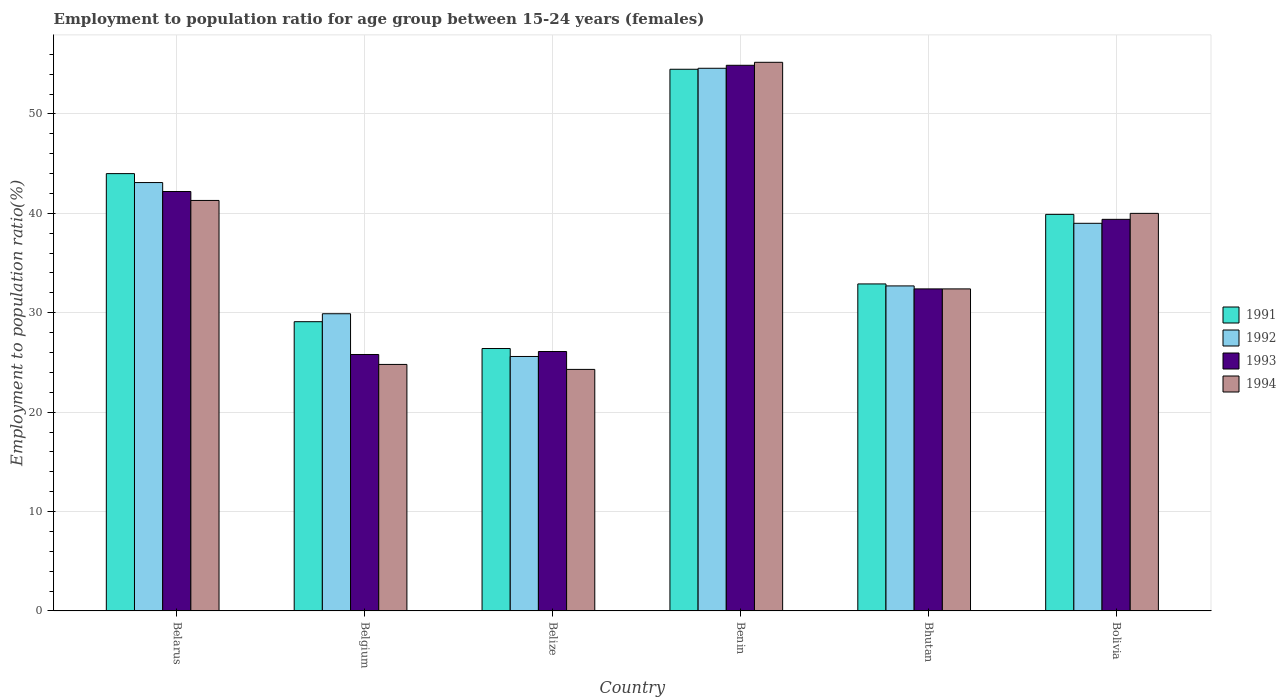How many groups of bars are there?
Provide a short and direct response. 6. Are the number of bars on each tick of the X-axis equal?
Your answer should be very brief. Yes. How many bars are there on the 6th tick from the right?
Offer a very short reply. 4. What is the label of the 5th group of bars from the left?
Provide a short and direct response. Bhutan. What is the employment to population ratio in 1994 in Belgium?
Offer a very short reply. 24.8. Across all countries, what is the maximum employment to population ratio in 1994?
Offer a very short reply. 55.2. Across all countries, what is the minimum employment to population ratio in 1992?
Give a very brief answer. 25.6. In which country was the employment to population ratio in 1991 maximum?
Keep it short and to the point. Benin. What is the total employment to population ratio in 1993 in the graph?
Offer a terse response. 220.8. What is the difference between the employment to population ratio in 1992 in Belize and that in Bolivia?
Offer a very short reply. -13.4. What is the difference between the employment to population ratio in 1994 in Belarus and the employment to population ratio in 1991 in Belize?
Provide a short and direct response. 14.9. What is the average employment to population ratio in 1993 per country?
Provide a short and direct response. 36.8. What is the difference between the employment to population ratio of/in 1993 and employment to population ratio of/in 1992 in Belarus?
Your response must be concise. -0.9. What is the ratio of the employment to population ratio in 1992 in Belgium to that in Benin?
Provide a succinct answer. 0.55. Is the employment to population ratio in 1992 in Belgium less than that in Bolivia?
Provide a succinct answer. Yes. What is the difference between the highest and the second highest employment to population ratio in 1992?
Offer a very short reply. -11.5. What is the difference between the highest and the lowest employment to population ratio in 1991?
Ensure brevity in your answer.  28.1. Is the sum of the employment to population ratio in 1992 in Belgium and Benin greater than the maximum employment to population ratio in 1994 across all countries?
Offer a very short reply. Yes. Is it the case that in every country, the sum of the employment to population ratio in 1992 and employment to population ratio in 1994 is greater than the sum of employment to population ratio in 1991 and employment to population ratio in 1993?
Your answer should be compact. No. What does the 4th bar from the right in Belarus represents?
Make the answer very short. 1991. How many countries are there in the graph?
Your answer should be compact. 6. What is the difference between two consecutive major ticks on the Y-axis?
Make the answer very short. 10. Are the values on the major ticks of Y-axis written in scientific E-notation?
Provide a succinct answer. No. Does the graph contain any zero values?
Provide a succinct answer. No. How many legend labels are there?
Your answer should be compact. 4. What is the title of the graph?
Ensure brevity in your answer.  Employment to population ratio for age group between 15-24 years (females). Does "2001" appear as one of the legend labels in the graph?
Provide a succinct answer. No. What is the label or title of the X-axis?
Provide a succinct answer. Country. What is the Employment to population ratio(%) in 1992 in Belarus?
Ensure brevity in your answer.  43.1. What is the Employment to population ratio(%) in 1993 in Belarus?
Ensure brevity in your answer.  42.2. What is the Employment to population ratio(%) in 1994 in Belarus?
Give a very brief answer. 41.3. What is the Employment to population ratio(%) of 1991 in Belgium?
Your answer should be very brief. 29.1. What is the Employment to population ratio(%) of 1992 in Belgium?
Your response must be concise. 29.9. What is the Employment to population ratio(%) in 1993 in Belgium?
Your answer should be very brief. 25.8. What is the Employment to population ratio(%) in 1994 in Belgium?
Your answer should be compact. 24.8. What is the Employment to population ratio(%) of 1991 in Belize?
Your response must be concise. 26.4. What is the Employment to population ratio(%) in 1992 in Belize?
Provide a short and direct response. 25.6. What is the Employment to population ratio(%) in 1993 in Belize?
Your answer should be very brief. 26.1. What is the Employment to population ratio(%) of 1994 in Belize?
Give a very brief answer. 24.3. What is the Employment to population ratio(%) of 1991 in Benin?
Provide a succinct answer. 54.5. What is the Employment to population ratio(%) of 1992 in Benin?
Your response must be concise. 54.6. What is the Employment to population ratio(%) in 1993 in Benin?
Your answer should be very brief. 54.9. What is the Employment to population ratio(%) of 1994 in Benin?
Provide a succinct answer. 55.2. What is the Employment to population ratio(%) of 1991 in Bhutan?
Your answer should be very brief. 32.9. What is the Employment to population ratio(%) in 1992 in Bhutan?
Offer a very short reply. 32.7. What is the Employment to population ratio(%) in 1993 in Bhutan?
Offer a terse response. 32.4. What is the Employment to population ratio(%) of 1994 in Bhutan?
Ensure brevity in your answer.  32.4. What is the Employment to population ratio(%) of 1991 in Bolivia?
Offer a terse response. 39.9. What is the Employment to population ratio(%) in 1992 in Bolivia?
Ensure brevity in your answer.  39. What is the Employment to population ratio(%) of 1993 in Bolivia?
Provide a succinct answer. 39.4. Across all countries, what is the maximum Employment to population ratio(%) in 1991?
Your answer should be very brief. 54.5. Across all countries, what is the maximum Employment to population ratio(%) in 1992?
Your answer should be compact. 54.6. Across all countries, what is the maximum Employment to population ratio(%) in 1993?
Provide a short and direct response. 54.9. Across all countries, what is the maximum Employment to population ratio(%) of 1994?
Keep it short and to the point. 55.2. Across all countries, what is the minimum Employment to population ratio(%) in 1991?
Make the answer very short. 26.4. Across all countries, what is the minimum Employment to population ratio(%) in 1992?
Your answer should be compact. 25.6. Across all countries, what is the minimum Employment to population ratio(%) in 1993?
Provide a succinct answer. 25.8. Across all countries, what is the minimum Employment to population ratio(%) of 1994?
Offer a very short reply. 24.3. What is the total Employment to population ratio(%) of 1991 in the graph?
Your response must be concise. 226.8. What is the total Employment to population ratio(%) in 1992 in the graph?
Ensure brevity in your answer.  224.9. What is the total Employment to population ratio(%) in 1993 in the graph?
Offer a very short reply. 220.8. What is the total Employment to population ratio(%) of 1994 in the graph?
Make the answer very short. 218. What is the difference between the Employment to population ratio(%) of 1991 in Belarus and that in Belgium?
Offer a terse response. 14.9. What is the difference between the Employment to population ratio(%) of 1993 in Belarus and that in Belgium?
Offer a very short reply. 16.4. What is the difference between the Employment to population ratio(%) of 1994 in Belarus and that in Belgium?
Offer a terse response. 16.5. What is the difference between the Employment to population ratio(%) of 1991 in Belarus and that in Belize?
Provide a succinct answer. 17.6. What is the difference between the Employment to population ratio(%) of 1991 in Belarus and that in Benin?
Offer a very short reply. -10.5. What is the difference between the Employment to population ratio(%) of 1992 in Belarus and that in Bhutan?
Your answer should be compact. 10.4. What is the difference between the Employment to population ratio(%) of 1993 in Belarus and that in Bhutan?
Offer a very short reply. 9.8. What is the difference between the Employment to population ratio(%) of 1994 in Belarus and that in Bhutan?
Ensure brevity in your answer.  8.9. What is the difference between the Employment to population ratio(%) of 1991 in Belarus and that in Bolivia?
Provide a succinct answer. 4.1. What is the difference between the Employment to population ratio(%) of 1993 in Belarus and that in Bolivia?
Give a very brief answer. 2.8. What is the difference between the Employment to population ratio(%) in 1993 in Belgium and that in Belize?
Your response must be concise. -0.3. What is the difference between the Employment to population ratio(%) in 1994 in Belgium and that in Belize?
Give a very brief answer. 0.5. What is the difference between the Employment to population ratio(%) in 1991 in Belgium and that in Benin?
Provide a succinct answer. -25.4. What is the difference between the Employment to population ratio(%) in 1992 in Belgium and that in Benin?
Provide a succinct answer. -24.7. What is the difference between the Employment to population ratio(%) in 1993 in Belgium and that in Benin?
Offer a very short reply. -29.1. What is the difference between the Employment to population ratio(%) of 1994 in Belgium and that in Benin?
Give a very brief answer. -30.4. What is the difference between the Employment to population ratio(%) of 1994 in Belgium and that in Bolivia?
Your answer should be very brief. -15.2. What is the difference between the Employment to population ratio(%) of 1991 in Belize and that in Benin?
Make the answer very short. -28.1. What is the difference between the Employment to population ratio(%) in 1992 in Belize and that in Benin?
Your response must be concise. -29. What is the difference between the Employment to population ratio(%) of 1993 in Belize and that in Benin?
Offer a terse response. -28.8. What is the difference between the Employment to population ratio(%) of 1994 in Belize and that in Benin?
Your response must be concise. -30.9. What is the difference between the Employment to population ratio(%) of 1991 in Belize and that in Bolivia?
Ensure brevity in your answer.  -13.5. What is the difference between the Employment to population ratio(%) of 1994 in Belize and that in Bolivia?
Ensure brevity in your answer.  -15.7. What is the difference between the Employment to population ratio(%) in 1991 in Benin and that in Bhutan?
Your answer should be very brief. 21.6. What is the difference between the Employment to population ratio(%) of 1992 in Benin and that in Bhutan?
Make the answer very short. 21.9. What is the difference between the Employment to population ratio(%) of 1993 in Benin and that in Bhutan?
Offer a very short reply. 22.5. What is the difference between the Employment to population ratio(%) of 1994 in Benin and that in Bhutan?
Offer a very short reply. 22.8. What is the difference between the Employment to population ratio(%) in 1991 in Benin and that in Bolivia?
Ensure brevity in your answer.  14.6. What is the difference between the Employment to population ratio(%) in 1993 in Benin and that in Bolivia?
Give a very brief answer. 15.5. What is the difference between the Employment to population ratio(%) in 1992 in Bhutan and that in Bolivia?
Make the answer very short. -6.3. What is the difference between the Employment to population ratio(%) in 1994 in Bhutan and that in Bolivia?
Offer a very short reply. -7.6. What is the difference between the Employment to population ratio(%) in 1991 in Belarus and the Employment to population ratio(%) in 1992 in Belgium?
Your answer should be compact. 14.1. What is the difference between the Employment to population ratio(%) of 1991 in Belarus and the Employment to population ratio(%) of 1994 in Belgium?
Provide a succinct answer. 19.2. What is the difference between the Employment to population ratio(%) of 1992 in Belarus and the Employment to population ratio(%) of 1994 in Belgium?
Make the answer very short. 18.3. What is the difference between the Employment to population ratio(%) in 1993 in Belarus and the Employment to population ratio(%) in 1994 in Belgium?
Make the answer very short. 17.4. What is the difference between the Employment to population ratio(%) of 1991 in Belarus and the Employment to population ratio(%) of 1992 in Belize?
Provide a succinct answer. 18.4. What is the difference between the Employment to population ratio(%) of 1992 in Belarus and the Employment to population ratio(%) of 1993 in Belize?
Provide a short and direct response. 17. What is the difference between the Employment to population ratio(%) in 1992 in Belarus and the Employment to population ratio(%) in 1994 in Belize?
Ensure brevity in your answer.  18.8. What is the difference between the Employment to population ratio(%) in 1991 in Belarus and the Employment to population ratio(%) in 1992 in Benin?
Offer a terse response. -10.6. What is the difference between the Employment to population ratio(%) of 1992 in Belarus and the Employment to population ratio(%) of 1993 in Benin?
Keep it short and to the point. -11.8. What is the difference between the Employment to population ratio(%) of 1993 in Belarus and the Employment to population ratio(%) of 1994 in Benin?
Offer a terse response. -13. What is the difference between the Employment to population ratio(%) in 1991 in Belarus and the Employment to population ratio(%) in 1994 in Bhutan?
Offer a very short reply. 11.6. What is the difference between the Employment to population ratio(%) of 1992 in Belarus and the Employment to population ratio(%) of 1994 in Bhutan?
Ensure brevity in your answer.  10.7. What is the difference between the Employment to population ratio(%) in 1993 in Belarus and the Employment to population ratio(%) in 1994 in Bhutan?
Offer a terse response. 9.8. What is the difference between the Employment to population ratio(%) in 1991 in Belarus and the Employment to population ratio(%) in 1993 in Bolivia?
Offer a very short reply. 4.6. What is the difference between the Employment to population ratio(%) in 1991 in Belarus and the Employment to population ratio(%) in 1994 in Bolivia?
Your response must be concise. 4. What is the difference between the Employment to population ratio(%) of 1991 in Belgium and the Employment to population ratio(%) of 1992 in Belize?
Make the answer very short. 3.5. What is the difference between the Employment to population ratio(%) of 1991 in Belgium and the Employment to population ratio(%) of 1993 in Belize?
Offer a terse response. 3. What is the difference between the Employment to population ratio(%) of 1991 in Belgium and the Employment to population ratio(%) of 1994 in Belize?
Provide a succinct answer. 4.8. What is the difference between the Employment to population ratio(%) in 1992 in Belgium and the Employment to population ratio(%) in 1993 in Belize?
Your answer should be very brief. 3.8. What is the difference between the Employment to population ratio(%) of 1992 in Belgium and the Employment to population ratio(%) of 1994 in Belize?
Provide a succinct answer. 5.6. What is the difference between the Employment to population ratio(%) in 1993 in Belgium and the Employment to population ratio(%) in 1994 in Belize?
Your response must be concise. 1.5. What is the difference between the Employment to population ratio(%) of 1991 in Belgium and the Employment to population ratio(%) of 1992 in Benin?
Offer a very short reply. -25.5. What is the difference between the Employment to population ratio(%) in 1991 in Belgium and the Employment to population ratio(%) in 1993 in Benin?
Provide a succinct answer. -25.8. What is the difference between the Employment to population ratio(%) in 1991 in Belgium and the Employment to population ratio(%) in 1994 in Benin?
Offer a very short reply. -26.1. What is the difference between the Employment to population ratio(%) in 1992 in Belgium and the Employment to population ratio(%) in 1993 in Benin?
Offer a very short reply. -25. What is the difference between the Employment to population ratio(%) of 1992 in Belgium and the Employment to population ratio(%) of 1994 in Benin?
Give a very brief answer. -25.3. What is the difference between the Employment to population ratio(%) of 1993 in Belgium and the Employment to population ratio(%) of 1994 in Benin?
Offer a terse response. -29.4. What is the difference between the Employment to population ratio(%) in 1991 in Belgium and the Employment to population ratio(%) in 1992 in Bhutan?
Ensure brevity in your answer.  -3.6. What is the difference between the Employment to population ratio(%) of 1992 in Belgium and the Employment to population ratio(%) of 1993 in Bhutan?
Provide a succinct answer. -2.5. What is the difference between the Employment to population ratio(%) of 1992 in Belgium and the Employment to population ratio(%) of 1994 in Bhutan?
Give a very brief answer. -2.5. What is the difference between the Employment to population ratio(%) of 1991 in Belgium and the Employment to population ratio(%) of 1992 in Bolivia?
Offer a terse response. -9.9. What is the difference between the Employment to population ratio(%) of 1992 in Belgium and the Employment to population ratio(%) of 1993 in Bolivia?
Ensure brevity in your answer.  -9.5. What is the difference between the Employment to population ratio(%) of 1991 in Belize and the Employment to population ratio(%) of 1992 in Benin?
Provide a short and direct response. -28.2. What is the difference between the Employment to population ratio(%) in 1991 in Belize and the Employment to population ratio(%) in 1993 in Benin?
Provide a short and direct response. -28.5. What is the difference between the Employment to population ratio(%) in 1991 in Belize and the Employment to population ratio(%) in 1994 in Benin?
Provide a succinct answer. -28.8. What is the difference between the Employment to population ratio(%) of 1992 in Belize and the Employment to population ratio(%) of 1993 in Benin?
Provide a succinct answer. -29.3. What is the difference between the Employment to population ratio(%) in 1992 in Belize and the Employment to population ratio(%) in 1994 in Benin?
Your answer should be very brief. -29.6. What is the difference between the Employment to population ratio(%) in 1993 in Belize and the Employment to population ratio(%) in 1994 in Benin?
Your answer should be compact. -29.1. What is the difference between the Employment to population ratio(%) of 1991 in Belize and the Employment to population ratio(%) of 1992 in Bhutan?
Provide a succinct answer. -6.3. What is the difference between the Employment to population ratio(%) of 1991 in Belize and the Employment to population ratio(%) of 1993 in Bhutan?
Ensure brevity in your answer.  -6. What is the difference between the Employment to population ratio(%) in 1991 in Belize and the Employment to population ratio(%) in 1992 in Bolivia?
Your response must be concise. -12.6. What is the difference between the Employment to population ratio(%) in 1991 in Belize and the Employment to population ratio(%) in 1993 in Bolivia?
Offer a terse response. -13. What is the difference between the Employment to population ratio(%) of 1991 in Belize and the Employment to population ratio(%) of 1994 in Bolivia?
Your answer should be very brief. -13.6. What is the difference between the Employment to population ratio(%) in 1992 in Belize and the Employment to population ratio(%) in 1993 in Bolivia?
Offer a very short reply. -13.8. What is the difference between the Employment to population ratio(%) in 1992 in Belize and the Employment to population ratio(%) in 1994 in Bolivia?
Provide a succinct answer. -14.4. What is the difference between the Employment to population ratio(%) of 1993 in Belize and the Employment to population ratio(%) of 1994 in Bolivia?
Give a very brief answer. -13.9. What is the difference between the Employment to population ratio(%) of 1991 in Benin and the Employment to population ratio(%) of 1992 in Bhutan?
Keep it short and to the point. 21.8. What is the difference between the Employment to population ratio(%) of 1991 in Benin and the Employment to population ratio(%) of 1993 in Bhutan?
Provide a succinct answer. 22.1. What is the difference between the Employment to population ratio(%) of 1991 in Benin and the Employment to population ratio(%) of 1994 in Bhutan?
Offer a terse response. 22.1. What is the difference between the Employment to population ratio(%) in 1992 in Benin and the Employment to population ratio(%) in 1993 in Bhutan?
Ensure brevity in your answer.  22.2. What is the difference between the Employment to population ratio(%) of 1992 in Benin and the Employment to population ratio(%) of 1994 in Bhutan?
Offer a very short reply. 22.2. What is the difference between the Employment to population ratio(%) in 1993 in Benin and the Employment to population ratio(%) in 1994 in Bhutan?
Ensure brevity in your answer.  22.5. What is the difference between the Employment to population ratio(%) in 1991 in Benin and the Employment to population ratio(%) in 1992 in Bolivia?
Give a very brief answer. 15.5. What is the difference between the Employment to population ratio(%) of 1991 in Benin and the Employment to population ratio(%) of 1993 in Bolivia?
Offer a terse response. 15.1. What is the difference between the Employment to population ratio(%) of 1991 in Benin and the Employment to population ratio(%) of 1994 in Bolivia?
Give a very brief answer. 14.5. What is the difference between the Employment to population ratio(%) in 1992 in Benin and the Employment to population ratio(%) in 1993 in Bolivia?
Provide a short and direct response. 15.2. What is the difference between the Employment to population ratio(%) in 1992 in Benin and the Employment to population ratio(%) in 1994 in Bolivia?
Keep it short and to the point. 14.6. What is the difference between the Employment to population ratio(%) of 1993 in Benin and the Employment to population ratio(%) of 1994 in Bolivia?
Your response must be concise. 14.9. What is the difference between the Employment to population ratio(%) of 1992 in Bhutan and the Employment to population ratio(%) of 1993 in Bolivia?
Ensure brevity in your answer.  -6.7. What is the difference between the Employment to population ratio(%) in 1993 in Bhutan and the Employment to population ratio(%) in 1994 in Bolivia?
Provide a succinct answer. -7.6. What is the average Employment to population ratio(%) of 1991 per country?
Ensure brevity in your answer.  37.8. What is the average Employment to population ratio(%) in 1992 per country?
Give a very brief answer. 37.48. What is the average Employment to population ratio(%) of 1993 per country?
Offer a very short reply. 36.8. What is the average Employment to population ratio(%) of 1994 per country?
Your response must be concise. 36.33. What is the difference between the Employment to population ratio(%) in 1991 and Employment to population ratio(%) in 1992 in Belarus?
Your answer should be compact. 0.9. What is the difference between the Employment to population ratio(%) in 1991 and Employment to population ratio(%) in 1993 in Belarus?
Your answer should be very brief. 1.8. What is the difference between the Employment to population ratio(%) of 1992 and Employment to population ratio(%) of 1994 in Belarus?
Offer a very short reply. 1.8. What is the difference between the Employment to population ratio(%) of 1993 and Employment to population ratio(%) of 1994 in Belarus?
Give a very brief answer. 0.9. What is the difference between the Employment to population ratio(%) in 1991 and Employment to population ratio(%) in 1992 in Belgium?
Your answer should be compact. -0.8. What is the difference between the Employment to population ratio(%) in 1992 and Employment to population ratio(%) in 1994 in Belgium?
Give a very brief answer. 5.1. What is the difference between the Employment to population ratio(%) of 1993 and Employment to population ratio(%) of 1994 in Belgium?
Provide a short and direct response. 1. What is the difference between the Employment to population ratio(%) of 1991 and Employment to population ratio(%) of 1992 in Belize?
Offer a terse response. 0.8. What is the difference between the Employment to population ratio(%) in 1991 and Employment to population ratio(%) in 1994 in Belize?
Keep it short and to the point. 2.1. What is the difference between the Employment to population ratio(%) of 1993 and Employment to population ratio(%) of 1994 in Belize?
Make the answer very short. 1.8. What is the difference between the Employment to population ratio(%) in 1991 and Employment to population ratio(%) in 1993 in Benin?
Your answer should be compact. -0.4. What is the difference between the Employment to population ratio(%) in 1991 and Employment to population ratio(%) in 1994 in Benin?
Your answer should be compact. -0.7. What is the difference between the Employment to population ratio(%) in 1992 and Employment to population ratio(%) in 1993 in Benin?
Keep it short and to the point. -0.3. What is the difference between the Employment to population ratio(%) of 1991 and Employment to population ratio(%) of 1993 in Bhutan?
Your answer should be very brief. 0.5. What is the difference between the Employment to population ratio(%) of 1992 and Employment to population ratio(%) of 1993 in Bhutan?
Your answer should be very brief. 0.3. What is the difference between the Employment to population ratio(%) of 1992 and Employment to population ratio(%) of 1994 in Bhutan?
Keep it short and to the point. 0.3. What is the difference between the Employment to population ratio(%) of 1991 and Employment to population ratio(%) of 1993 in Bolivia?
Your response must be concise. 0.5. What is the difference between the Employment to population ratio(%) of 1991 and Employment to population ratio(%) of 1994 in Bolivia?
Give a very brief answer. -0.1. What is the difference between the Employment to population ratio(%) of 1992 and Employment to population ratio(%) of 1993 in Bolivia?
Provide a short and direct response. -0.4. What is the difference between the Employment to population ratio(%) in 1992 and Employment to population ratio(%) in 1994 in Bolivia?
Your answer should be compact. -1. What is the ratio of the Employment to population ratio(%) of 1991 in Belarus to that in Belgium?
Ensure brevity in your answer.  1.51. What is the ratio of the Employment to population ratio(%) of 1992 in Belarus to that in Belgium?
Provide a short and direct response. 1.44. What is the ratio of the Employment to population ratio(%) of 1993 in Belarus to that in Belgium?
Give a very brief answer. 1.64. What is the ratio of the Employment to population ratio(%) in 1994 in Belarus to that in Belgium?
Ensure brevity in your answer.  1.67. What is the ratio of the Employment to population ratio(%) in 1991 in Belarus to that in Belize?
Provide a succinct answer. 1.67. What is the ratio of the Employment to population ratio(%) in 1992 in Belarus to that in Belize?
Keep it short and to the point. 1.68. What is the ratio of the Employment to population ratio(%) in 1993 in Belarus to that in Belize?
Provide a short and direct response. 1.62. What is the ratio of the Employment to population ratio(%) in 1994 in Belarus to that in Belize?
Keep it short and to the point. 1.7. What is the ratio of the Employment to population ratio(%) of 1991 in Belarus to that in Benin?
Keep it short and to the point. 0.81. What is the ratio of the Employment to population ratio(%) in 1992 in Belarus to that in Benin?
Make the answer very short. 0.79. What is the ratio of the Employment to population ratio(%) in 1993 in Belarus to that in Benin?
Offer a very short reply. 0.77. What is the ratio of the Employment to population ratio(%) in 1994 in Belarus to that in Benin?
Keep it short and to the point. 0.75. What is the ratio of the Employment to population ratio(%) in 1991 in Belarus to that in Bhutan?
Ensure brevity in your answer.  1.34. What is the ratio of the Employment to population ratio(%) of 1992 in Belarus to that in Bhutan?
Your response must be concise. 1.32. What is the ratio of the Employment to population ratio(%) in 1993 in Belarus to that in Bhutan?
Your answer should be compact. 1.3. What is the ratio of the Employment to population ratio(%) of 1994 in Belarus to that in Bhutan?
Give a very brief answer. 1.27. What is the ratio of the Employment to population ratio(%) of 1991 in Belarus to that in Bolivia?
Give a very brief answer. 1.1. What is the ratio of the Employment to population ratio(%) of 1992 in Belarus to that in Bolivia?
Give a very brief answer. 1.11. What is the ratio of the Employment to population ratio(%) in 1993 in Belarus to that in Bolivia?
Keep it short and to the point. 1.07. What is the ratio of the Employment to population ratio(%) in 1994 in Belarus to that in Bolivia?
Your answer should be very brief. 1.03. What is the ratio of the Employment to population ratio(%) of 1991 in Belgium to that in Belize?
Your answer should be very brief. 1.1. What is the ratio of the Employment to population ratio(%) of 1992 in Belgium to that in Belize?
Your answer should be very brief. 1.17. What is the ratio of the Employment to population ratio(%) of 1994 in Belgium to that in Belize?
Ensure brevity in your answer.  1.02. What is the ratio of the Employment to population ratio(%) in 1991 in Belgium to that in Benin?
Ensure brevity in your answer.  0.53. What is the ratio of the Employment to population ratio(%) of 1992 in Belgium to that in Benin?
Make the answer very short. 0.55. What is the ratio of the Employment to population ratio(%) of 1993 in Belgium to that in Benin?
Provide a succinct answer. 0.47. What is the ratio of the Employment to population ratio(%) in 1994 in Belgium to that in Benin?
Your response must be concise. 0.45. What is the ratio of the Employment to population ratio(%) of 1991 in Belgium to that in Bhutan?
Give a very brief answer. 0.88. What is the ratio of the Employment to population ratio(%) in 1992 in Belgium to that in Bhutan?
Your answer should be compact. 0.91. What is the ratio of the Employment to population ratio(%) in 1993 in Belgium to that in Bhutan?
Offer a very short reply. 0.8. What is the ratio of the Employment to population ratio(%) of 1994 in Belgium to that in Bhutan?
Your response must be concise. 0.77. What is the ratio of the Employment to population ratio(%) of 1991 in Belgium to that in Bolivia?
Your answer should be very brief. 0.73. What is the ratio of the Employment to population ratio(%) of 1992 in Belgium to that in Bolivia?
Provide a succinct answer. 0.77. What is the ratio of the Employment to population ratio(%) of 1993 in Belgium to that in Bolivia?
Offer a terse response. 0.65. What is the ratio of the Employment to population ratio(%) of 1994 in Belgium to that in Bolivia?
Make the answer very short. 0.62. What is the ratio of the Employment to population ratio(%) in 1991 in Belize to that in Benin?
Provide a short and direct response. 0.48. What is the ratio of the Employment to population ratio(%) of 1992 in Belize to that in Benin?
Provide a succinct answer. 0.47. What is the ratio of the Employment to population ratio(%) of 1993 in Belize to that in Benin?
Give a very brief answer. 0.48. What is the ratio of the Employment to population ratio(%) in 1994 in Belize to that in Benin?
Give a very brief answer. 0.44. What is the ratio of the Employment to population ratio(%) in 1991 in Belize to that in Bhutan?
Make the answer very short. 0.8. What is the ratio of the Employment to population ratio(%) of 1992 in Belize to that in Bhutan?
Offer a very short reply. 0.78. What is the ratio of the Employment to population ratio(%) in 1993 in Belize to that in Bhutan?
Provide a succinct answer. 0.81. What is the ratio of the Employment to population ratio(%) of 1994 in Belize to that in Bhutan?
Make the answer very short. 0.75. What is the ratio of the Employment to population ratio(%) of 1991 in Belize to that in Bolivia?
Keep it short and to the point. 0.66. What is the ratio of the Employment to population ratio(%) of 1992 in Belize to that in Bolivia?
Your answer should be compact. 0.66. What is the ratio of the Employment to population ratio(%) of 1993 in Belize to that in Bolivia?
Provide a succinct answer. 0.66. What is the ratio of the Employment to population ratio(%) in 1994 in Belize to that in Bolivia?
Your answer should be compact. 0.61. What is the ratio of the Employment to population ratio(%) of 1991 in Benin to that in Bhutan?
Your response must be concise. 1.66. What is the ratio of the Employment to population ratio(%) of 1992 in Benin to that in Bhutan?
Provide a succinct answer. 1.67. What is the ratio of the Employment to population ratio(%) in 1993 in Benin to that in Bhutan?
Your answer should be very brief. 1.69. What is the ratio of the Employment to population ratio(%) of 1994 in Benin to that in Bhutan?
Offer a very short reply. 1.7. What is the ratio of the Employment to population ratio(%) in 1991 in Benin to that in Bolivia?
Offer a very short reply. 1.37. What is the ratio of the Employment to population ratio(%) in 1993 in Benin to that in Bolivia?
Keep it short and to the point. 1.39. What is the ratio of the Employment to population ratio(%) in 1994 in Benin to that in Bolivia?
Ensure brevity in your answer.  1.38. What is the ratio of the Employment to population ratio(%) in 1991 in Bhutan to that in Bolivia?
Make the answer very short. 0.82. What is the ratio of the Employment to population ratio(%) of 1992 in Bhutan to that in Bolivia?
Keep it short and to the point. 0.84. What is the ratio of the Employment to population ratio(%) of 1993 in Bhutan to that in Bolivia?
Provide a succinct answer. 0.82. What is the ratio of the Employment to population ratio(%) of 1994 in Bhutan to that in Bolivia?
Offer a terse response. 0.81. What is the difference between the highest and the second highest Employment to population ratio(%) in 1991?
Your answer should be very brief. 10.5. What is the difference between the highest and the second highest Employment to population ratio(%) of 1993?
Ensure brevity in your answer.  12.7. What is the difference between the highest and the second highest Employment to population ratio(%) of 1994?
Your response must be concise. 13.9. What is the difference between the highest and the lowest Employment to population ratio(%) in 1991?
Your answer should be very brief. 28.1. What is the difference between the highest and the lowest Employment to population ratio(%) of 1993?
Provide a short and direct response. 29.1. What is the difference between the highest and the lowest Employment to population ratio(%) in 1994?
Give a very brief answer. 30.9. 